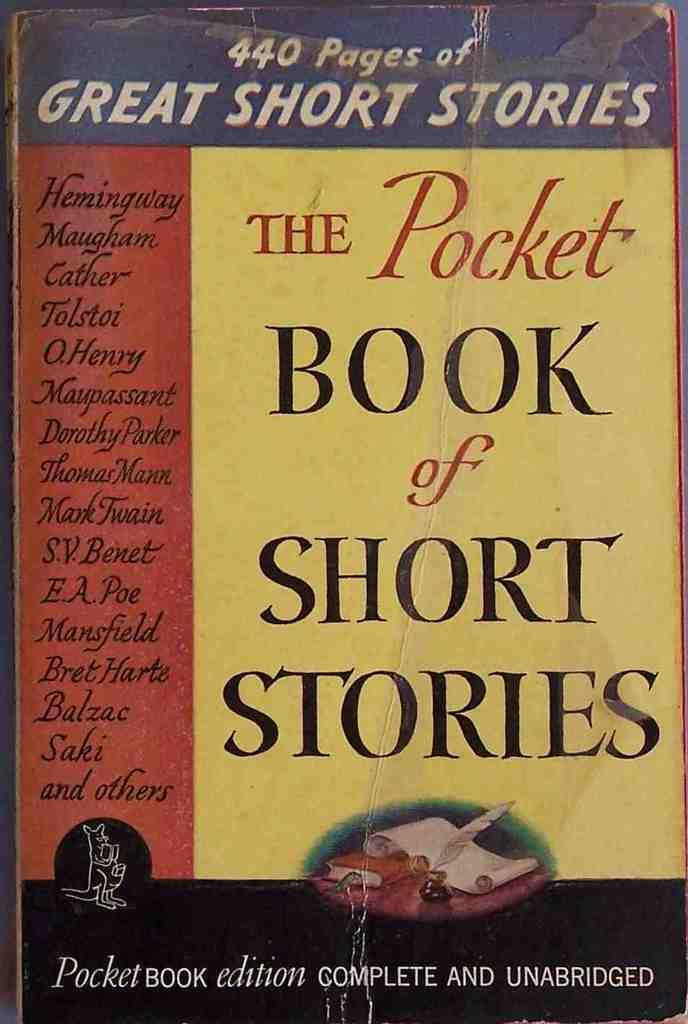<image>
Provide a brief description of the given image. The cover of the Pocket Book of Short Stories can be seen. 